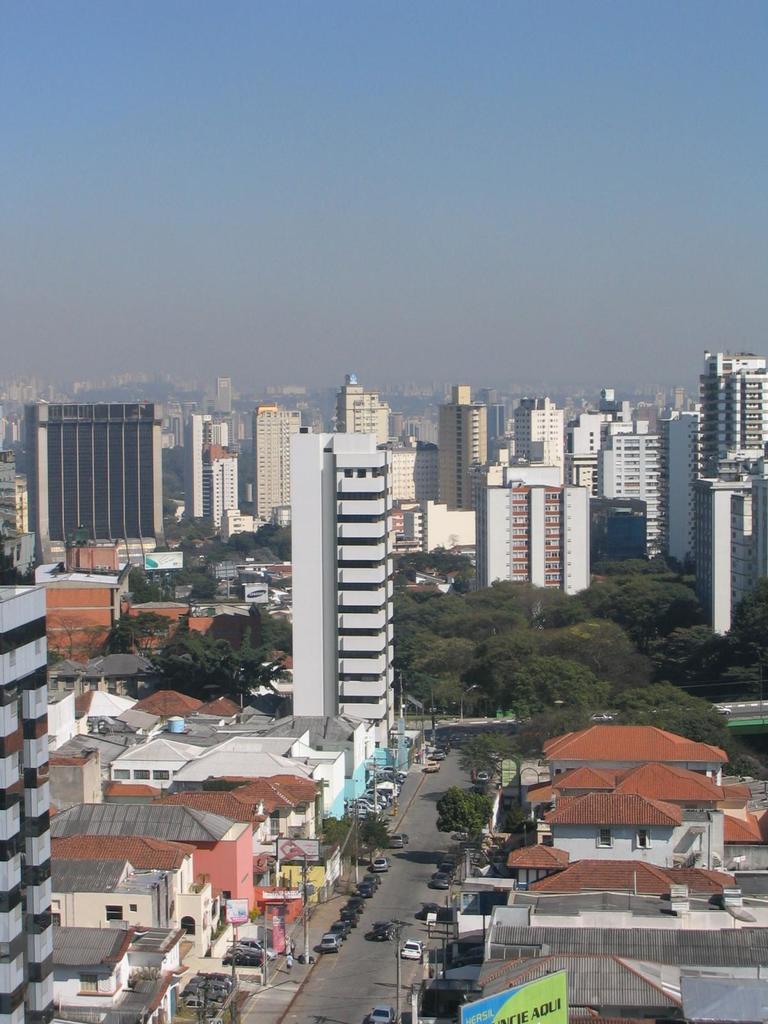Could you give a brief overview of what you see in this image? It is the image of a beautiful city it looks like a prosperous city, there are many buildings and houses, in between the buildings there are a lot of trees and there is a road between the houses and many vehicles are moving on the road. 